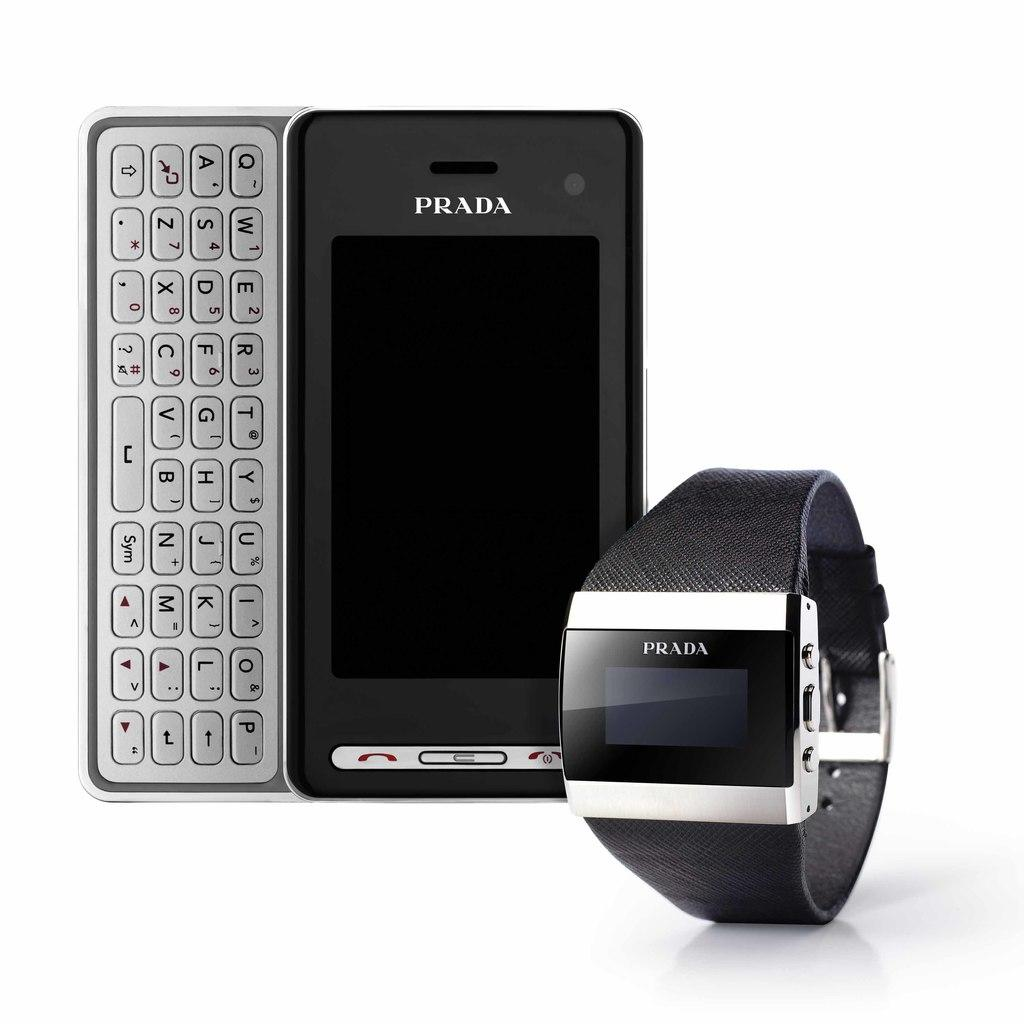<image>
Render a clear and concise summary of the photo. A bundle of Prada luxury electronics, A smart watch and cell phone key bored. 